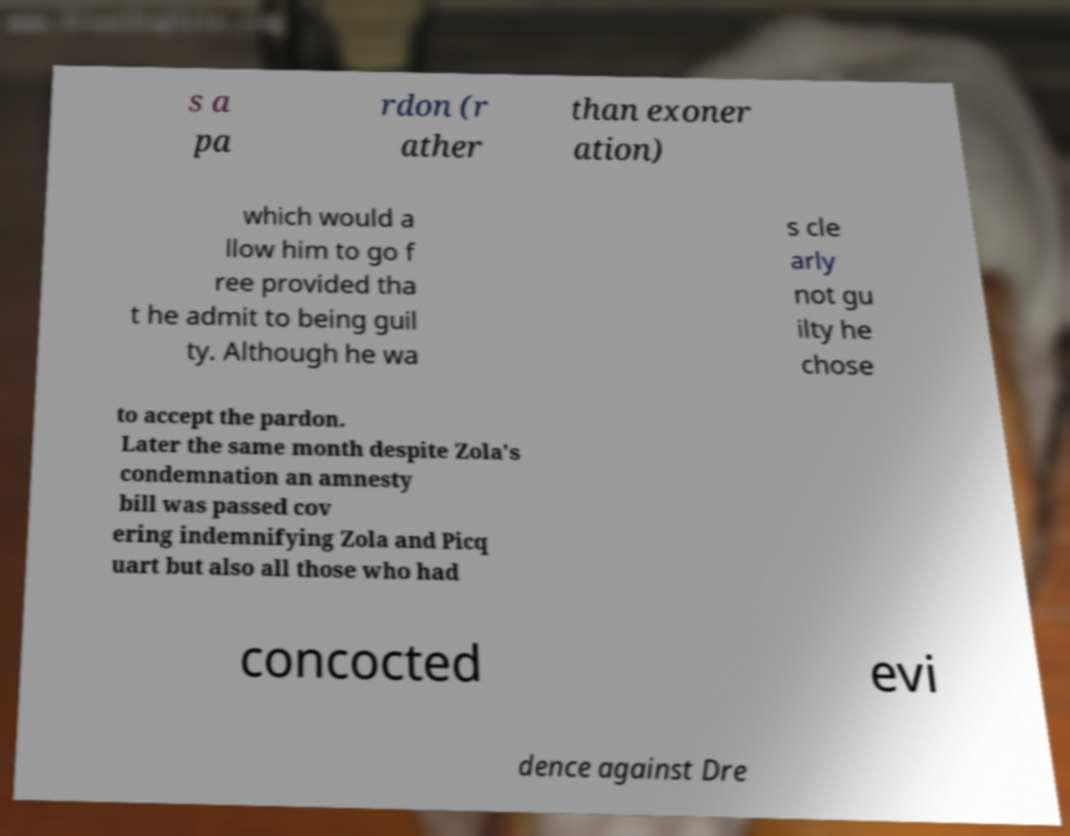Please identify and transcribe the text found in this image. s a pa rdon (r ather than exoner ation) which would a llow him to go f ree provided tha t he admit to being guil ty. Although he wa s cle arly not gu ilty he chose to accept the pardon. Later the same month despite Zola's condemnation an amnesty bill was passed cov ering indemnifying Zola and Picq uart but also all those who had concocted evi dence against Dre 